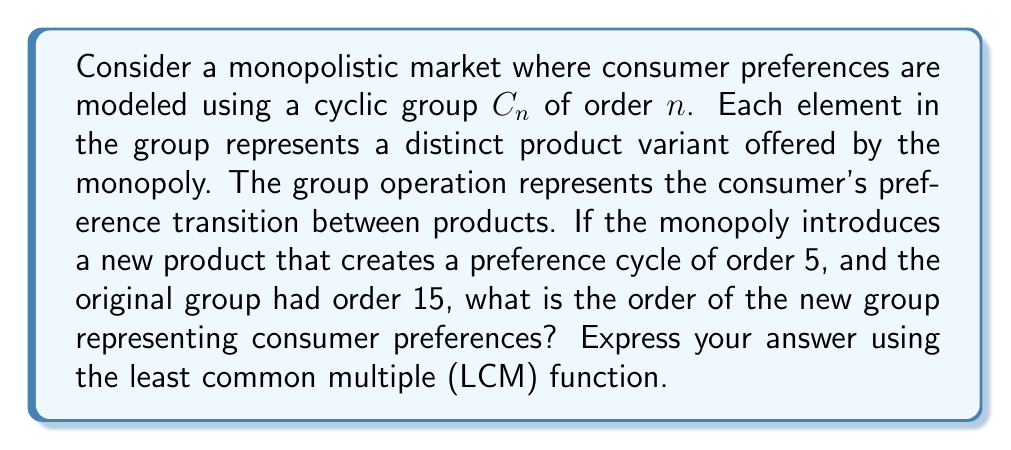Can you answer this question? To solve this problem, we need to understand how the introduction of a new product affects the structure of the consumer preference group:

1) Initially, consumer preferences are modeled by a cyclic group $C_{15}$ of order 15.

2) The introduction of a new product creates a preference cycle of order 5.

3) In abstract algebra, when we combine two cyclic groups, the resulting group's order is the least common multiple (LCM) of the orders of the original groups.

4) Therefore, the order of the new group will be:

   $$\text{LCM}(15, 5)$$

5) To calculate this:
   - Factor 15 = 3 * 5
   - Factor 5 = 5
   
6) The LCM will include the highest power of each prime factor:
   
   $$\text{LCM}(15, 5) = 3 * 5 = 15$$

This means that introducing the new product doesn't change the order of the group, but it does change its structure. The new group is still cyclic, but the preference transitions have been reorganized.

This result illustrates an important concept in monopoly analysis: sometimes, introducing new products may not expand the market (increase the order of the preference group) but instead reorganize existing preferences.
Answer: The order of the new group representing consumer preferences is $\text{LCM}(15, 5) = 15$. 